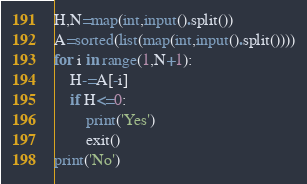Convert code to text. <code><loc_0><loc_0><loc_500><loc_500><_Python_>H,N=map(int,input().split())
A=sorted(list(map(int,input().split())))
for i in range(1,N+1):
    H-=A[-i]
    if H<=0:
        print('Yes')
        exit()
print('No')</code> 